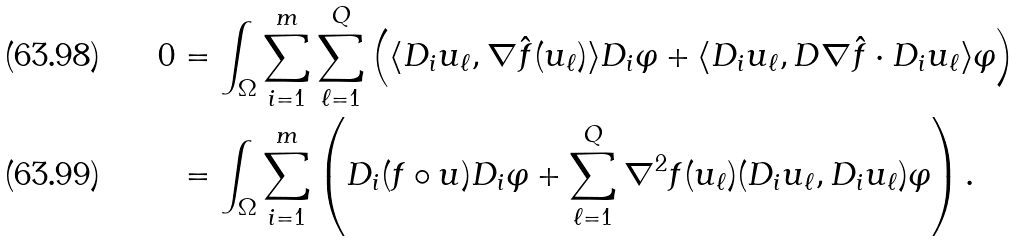Convert formula to latex. <formula><loc_0><loc_0><loc_500><loc_500>0 & = \int _ { \Omega } \sum _ { i = 1 } ^ { m } \sum _ { \ell = 1 } ^ { Q } \left ( \langle D _ { i } u _ { \ell } , \nabla \hat { f } ( u _ { \ell } ) \rangle D _ { i } \varphi + \langle D _ { i } u _ { \ell } , D \nabla \hat { f } \cdot D _ { i } u _ { \ell } \rangle \varphi \right ) \\ & = \int _ { \Omega } \sum _ { i = 1 } ^ { m } \left ( D _ { i } ( f \circ u ) D _ { i } \varphi + \sum _ { \ell = 1 } ^ { Q } \nabla ^ { 2 } f ( u _ { \ell } ) ( D _ { i } u _ { \ell } , D _ { i } u _ { \ell } ) \varphi \right ) .</formula> 